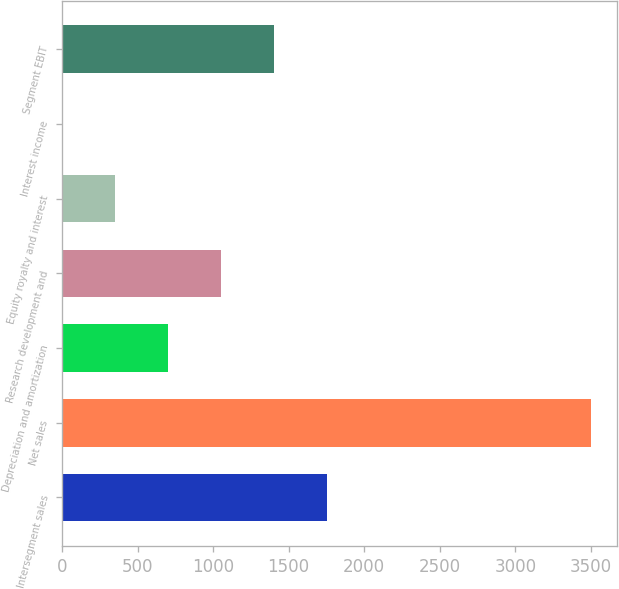<chart> <loc_0><loc_0><loc_500><loc_500><bar_chart><fcel>Intersegment sales<fcel>Net sales<fcel>Depreciation and amortization<fcel>Research development and<fcel>Equity royalty and interest<fcel>Interest income<fcel>Segment EBIT<nl><fcel>1751.5<fcel>3500<fcel>702.4<fcel>1052.1<fcel>352.7<fcel>3<fcel>1401.8<nl></chart> 